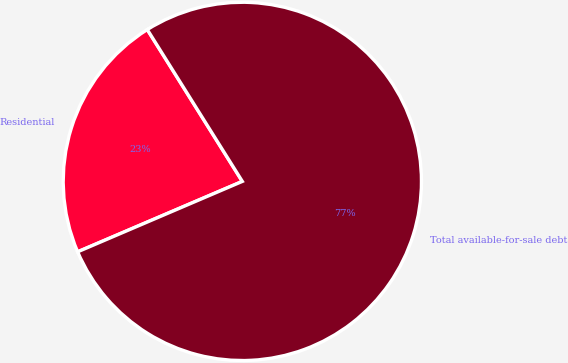<chart> <loc_0><loc_0><loc_500><loc_500><pie_chart><fcel>Residential<fcel>Total available-for-sale debt<nl><fcel>22.53%<fcel>77.47%<nl></chart> 